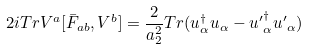Convert formula to latex. <formula><loc_0><loc_0><loc_500><loc_500>2 i T r V ^ { a } [ { \bar { F } } _ { a b } , V ^ { b } ] = \frac { 2 } { a ^ { 2 } _ { 2 } } T r ( u ^ { \dag } _ { \alpha } u _ { \alpha } - { u ^ { \prime } } ^ { \dag } _ { \alpha } { u ^ { \prime } } _ { \alpha } )</formula> 